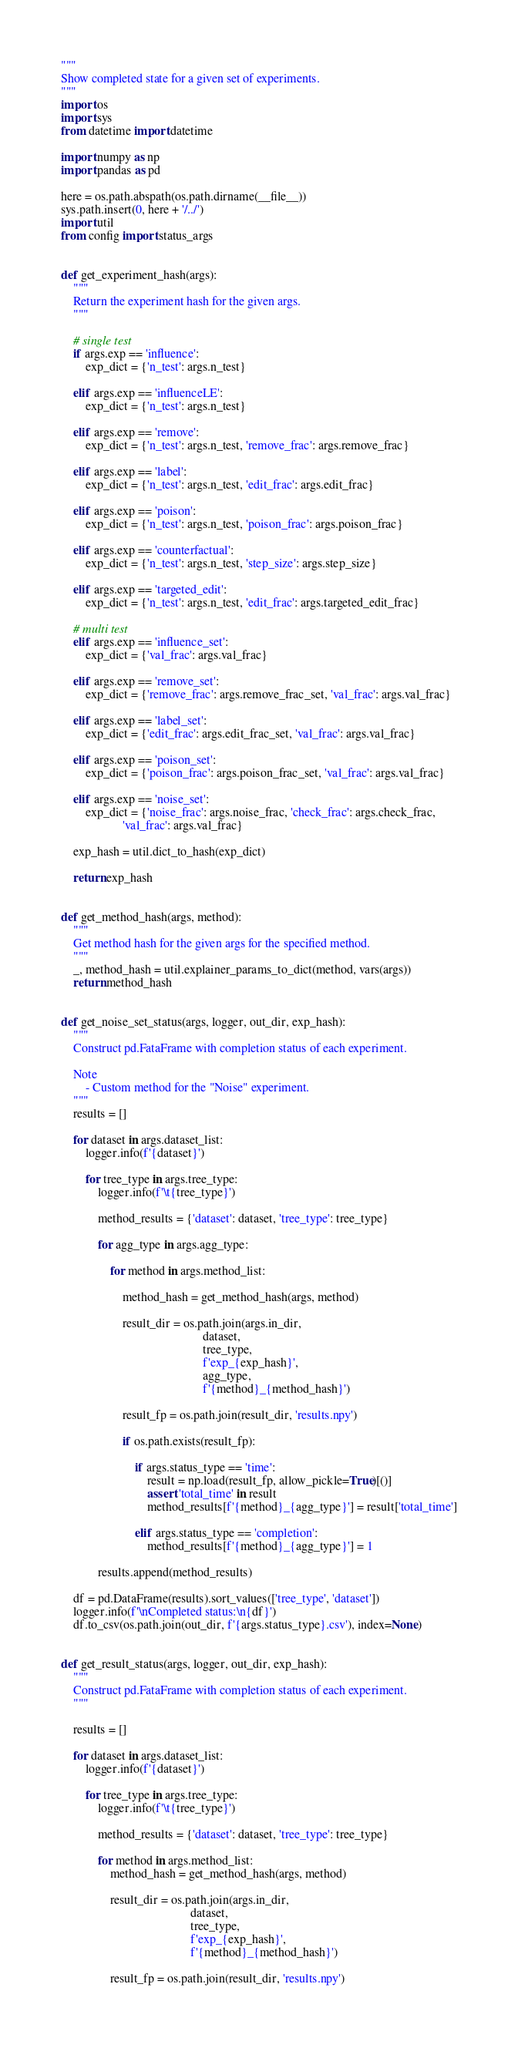<code> <loc_0><loc_0><loc_500><loc_500><_Python_>"""
Show completed state for a given set of experiments.
"""
import os
import sys
from datetime import datetime

import numpy as np
import pandas as pd

here = os.path.abspath(os.path.dirname(__file__))
sys.path.insert(0, here + '/../')
import util
from config import status_args


def get_experiment_hash(args):
    """
    Return the experiment hash for the given args.
    """

    # single test
    if args.exp == 'influence':
        exp_dict = {'n_test': args.n_test}

    elif args.exp == 'influenceLE':
        exp_dict = {'n_test': args.n_test}

    elif args.exp == 'remove':
        exp_dict = {'n_test': args.n_test, 'remove_frac': args.remove_frac}

    elif args.exp == 'label':
        exp_dict = {'n_test': args.n_test, 'edit_frac': args.edit_frac}

    elif args.exp == 'poison':
        exp_dict = {'n_test': args.n_test, 'poison_frac': args.poison_frac}

    elif args.exp == 'counterfactual':
        exp_dict = {'n_test': args.n_test, 'step_size': args.step_size}

    elif args.exp == 'targeted_edit':
        exp_dict = {'n_test': args.n_test, 'edit_frac': args.targeted_edit_frac}

    # multi test
    elif args.exp == 'influence_set':
        exp_dict = {'val_frac': args.val_frac}

    elif args.exp == 'remove_set':
        exp_dict = {'remove_frac': args.remove_frac_set, 'val_frac': args.val_frac}

    elif args.exp == 'label_set':
        exp_dict = {'edit_frac': args.edit_frac_set, 'val_frac': args.val_frac}

    elif args.exp == 'poison_set':
        exp_dict = {'poison_frac': args.poison_frac_set, 'val_frac': args.val_frac}

    elif args.exp == 'noise_set':
        exp_dict = {'noise_frac': args.noise_frac, 'check_frac': args.check_frac,
                    'val_frac': args.val_frac}

    exp_hash = util.dict_to_hash(exp_dict)

    return exp_hash


def get_method_hash(args, method):
    """
    Get method hash for the given args for the specified method.
    """
    _, method_hash = util.explainer_params_to_dict(method, vars(args))
    return method_hash


def get_noise_set_status(args, logger, out_dir, exp_hash):
    """
    Construct pd.FataFrame with completion status of each experiment.

    Note
        - Custom method for the "Noise" experiment.
    """
    results = []
    
    for dataset in args.dataset_list:
        logger.info(f'{dataset}')

        for tree_type in args.tree_type:
            logger.info(f'\t{tree_type}')

            method_results = {'dataset': dataset, 'tree_type': tree_type}

            for agg_type in args.agg_type:

                for method in args.method_list:

                    method_hash = get_method_hash(args, method)

                    result_dir = os.path.join(args.in_dir,
                                              dataset,
                                              tree_type,
                                              f'exp_{exp_hash}',
                                              agg_type,
                                              f'{method}_{method_hash}')

                    result_fp = os.path.join(result_dir, 'results.npy')

                    if os.path.exists(result_fp):

                        if args.status_type == 'time':
                            result = np.load(result_fp, allow_pickle=True)[()]
                            assert 'total_time' in result
                            method_results[f'{method}_{agg_type}'] = result['total_time']

                        elif args.status_type == 'completion':
                            method_results[f'{method}_{agg_type}'] = 1

            results.append(method_results)

    df = pd.DataFrame(results).sort_values(['tree_type', 'dataset'])
    logger.info(f'\nCompleted status:\n{df}')
    df.to_csv(os.path.join(out_dir, f'{args.status_type}.csv'), index=None)


def get_result_status(args, logger, out_dir, exp_hash):
    """
    Construct pd.FataFrame with completion status of each experiment.
    """

    results = []
    
    for dataset in args.dataset_list:
        logger.info(f'{dataset}')

        for tree_type in args.tree_type:
            logger.info(f'\t{tree_type}')

            method_results = {'dataset': dataset, 'tree_type': tree_type}

            for method in args.method_list:
                method_hash = get_method_hash(args, method)

                result_dir = os.path.join(args.in_dir,
                                          dataset,
                                          tree_type,
                                          f'exp_{exp_hash}',
                                          f'{method}_{method_hash}')

                result_fp = os.path.join(result_dir, 'results.npy')
</code> 